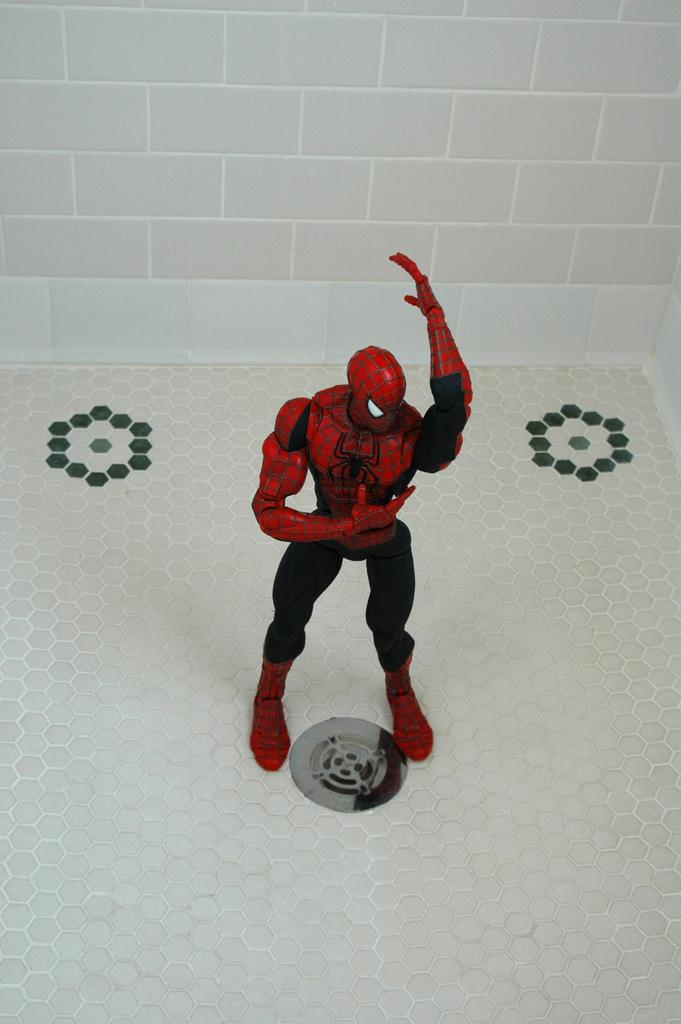What is the main subject of the image? There is a spider man statue in the image. What colors are used for the spider man statue? The spider man statue has red and black colors. What can be seen in the background of the image? There is a white color brick wall in the background of the image. What type of advice is the spider man statue giving in the image? The spider man statue is not giving any advice in the image, as it is a statue and not a living being. 